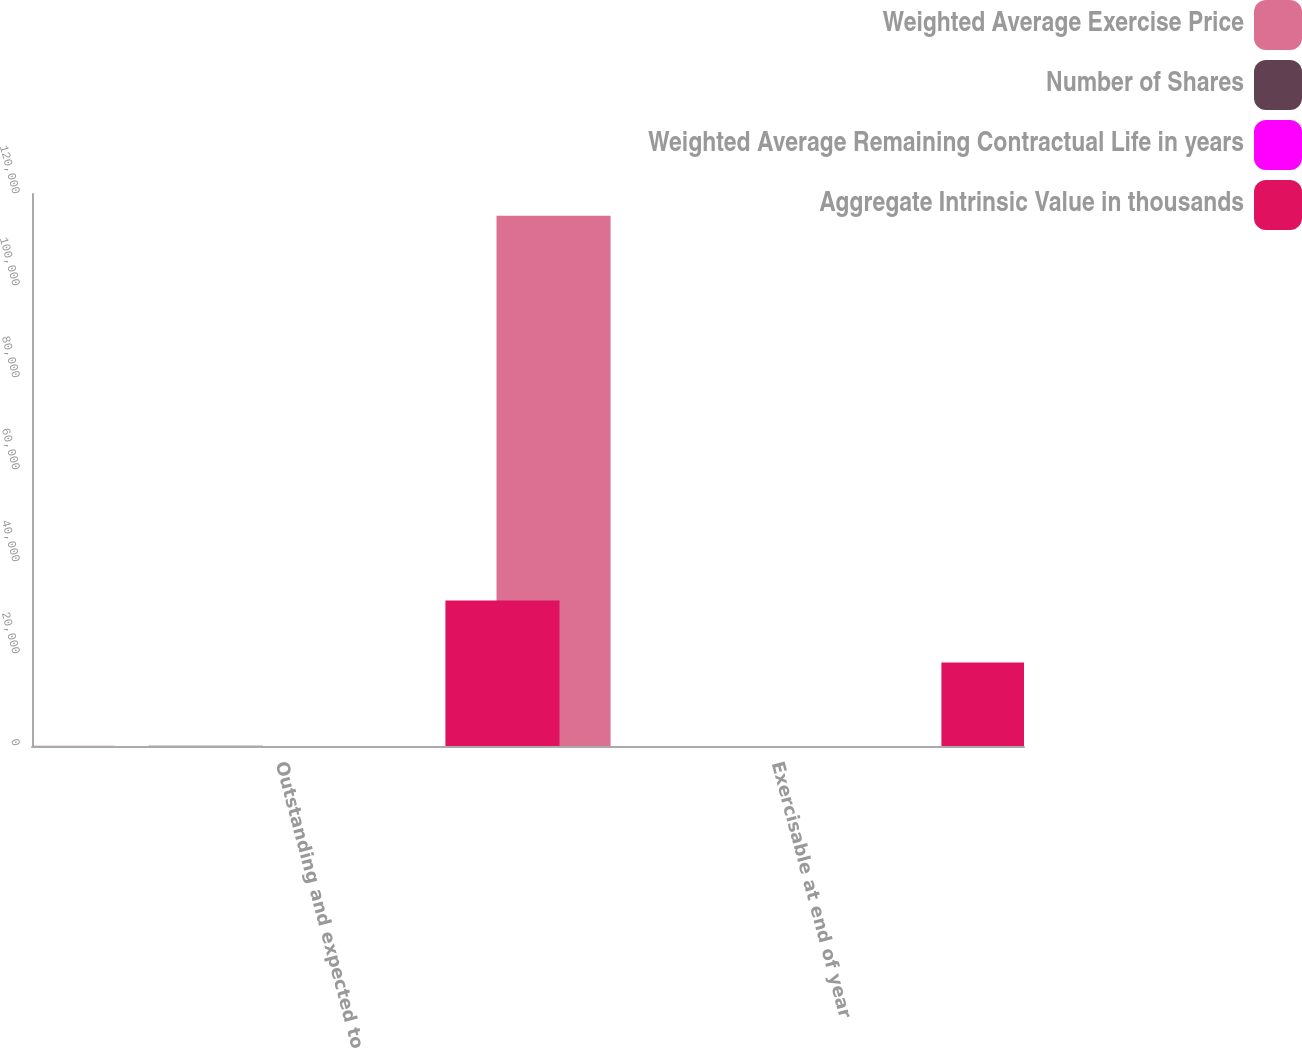<chart> <loc_0><loc_0><loc_500><loc_500><stacked_bar_chart><ecel><fcel>Outstanding and expected to<fcel>Exercisable at end of year<nl><fcel>Weighted Average Exercise Price<fcel>74.9<fcel>115290<nl><fcel>Number of Shares<fcel>74.9<fcel>26.74<nl><fcel>Weighted Average Remaining Contractual Life in years<fcel>6.8<fcel>5.48<nl><fcel>Aggregate Intrinsic Value in thousands<fcel>31651<fcel>18139<nl></chart> 